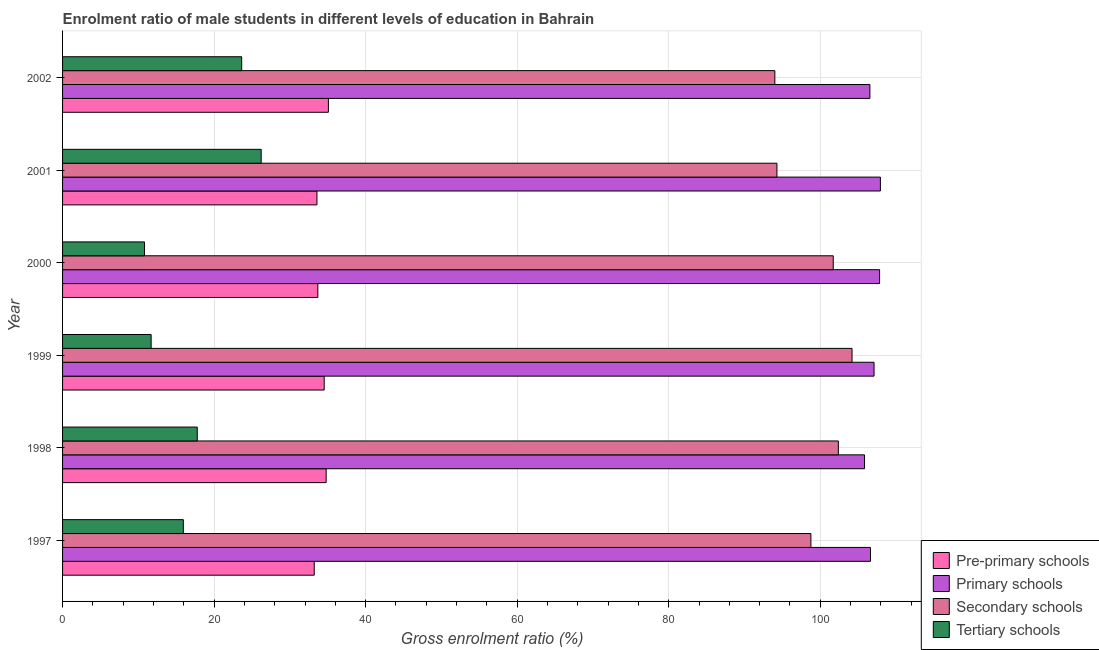How many different coloured bars are there?
Your answer should be very brief. 4. Are the number of bars on each tick of the Y-axis equal?
Your response must be concise. Yes. How many bars are there on the 2nd tick from the top?
Keep it short and to the point. 4. How many bars are there on the 3rd tick from the bottom?
Offer a very short reply. 4. What is the label of the 3rd group of bars from the top?
Your answer should be compact. 2000. What is the gross enrolment ratio(female) in primary schools in 1999?
Offer a very short reply. 107.1. Across all years, what is the maximum gross enrolment ratio(female) in primary schools?
Your answer should be compact. 107.94. Across all years, what is the minimum gross enrolment ratio(female) in tertiary schools?
Keep it short and to the point. 10.81. In which year was the gross enrolment ratio(female) in primary schools minimum?
Make the answer very short. 1998. What is the total gross enrolment ratio(female) in secondary schools in the graph?
Offer a very short reply. 595.35. What is the difference between the gross enrolment ratio(female) in secondary schools in 1999 and that in 2002?
Ensure brevity in your answer.  10.19. What is the difference between the gross enrolment ratio(female) in pre-primary schools in 1999 and the gross enrolment ratio(female) in secondary schools in 1998?
Keep it short and to the point. -67.86. What is the average gross enrolment ratio(female) in pre-primary schools per year?
Make the answer very short. 34.15. In the year 2001, what is the difference between the gross enrolment ratio(female) in tertiary schools and gross enrolment ratio(female) in primary schools?
Make the answer very short. -81.72. Is the difference between the gross enrolment ratio(female) in tertiary schools in 1999 and 2000 greater than the difference between the gross enrolment ratio(female) in secondary schools in 1999 and 2000?
Your answer should be compact. No. What is the difference between the highest and the second highest gross enrolment ratio(female) in primary schools?
Make the answer very short. 0.11. What is the difference between the highest and the lowest gross enrolment ratio(female) in primary schools?
Your response must be concise. 2.09. Is the sum of the gross enrolment ratio(female) in primary schools in 1997 and 1999 greater than the maximum gross enrolment ratio(female) in pre-primary schools across all years?
Give a very brief answer. Yes. What does the 4th bar from the top in 1999 represents?
Provide a short and direct response. Pre-primary schools. What does the 3rd bar from the bottom in 1997 represents?
Provide a short and direct response. Secondary schools. Is it the case that in every year, the sum of the gross enrolment ratio(female) in pre-primary schools and gross enrolment ratio(female) in primary schools is greater than the gross enrolment ratio(female) in secondary schools?
Provide a short and direct response. Yes. How many bars are there?
Offer a terse response. 24. Are all the bars in the graph horizontal?
Offer a very short reply. Yes. What is the difference between two consecutive major ticks on the X-axis?
Offer a very short reply. 20. What is the title of the graph?
Make the answer very short. Enrolment ratio of male students in different levels of education in Bahrain. What is the label or title of the Y-axis?
Your answer should be compact. Year. What is the Gross enrolment ratio (%) in Pre-primary schools in 1997?
Give a very brief answer. 33.22. What is the Gross enrolment ratio (%) of Primary schools in 1997?
Provide a short and direct response. 106.63. What is the Gross enrolment ratio (%) of Secondary schools in 1997?
Offer a terse response. 98.76. What is the Gross enrolment ratio (%) in Tertiary schools in 1997?
Ensure brevity in your answer.  15.94. What is the Gross enrolment ratio (%) in Pre-primary schools in 1998?
Give a very brief answer. 34.79. What is the Gross enrolment ratio (%) in Primary schools in 1998?
Provide a short and direct response. 105.84. What is the Gross enrolment ratio (%) in Secondary schools in 1998?
Your answer should be very brief. 102.39. What is the Gross enrolment ratio (%) of Tertiary schools in 1998?
Your answer should be very brief. 17.78. What is the Gross enrolment ratio (%) of Pre-primary schools in 1999?
Provide a succinct answer. 34.53. What is the Gross enrolment ratio (%) in Primary schools in 1999?
Your answer should be very brief. 107.1. What is the Gross enrolment ratio (%) of Secondary schools in 1999?
Give a very brief answer. 104.19. What is the Gross enrolment ratio (%) in Tertiary schools in 1999?
Your answer should be compact. 11.69. What is the Gross enrolment ratio (%) in Pre-primary schools in 2000?
Ensure brevity in your answer.  33.69. What is the Gross enrolment ratio (%) of Primary schools in 2000?
Ensure brevity in your answer.  107.83. What is the Gross enrolment ratio (%) in Secondary schools in 2000?
Your answer should be compact. 101.72. What is the Gross enrolment ratio (%) of Tertiary schools in 2000?
Make the answer very short. 10.81. What is the Gross enrolment ratio (%) of Pre-primary schools in 2001?
Make the answer very short. 33.57. What is the Gross enrolment ratio (%) in Primary schools in 2001?
Give a very brief answer. 107.94. What is the Gross enrolment ratio (%) of Secondary schools in 2001?
Your response must be concise. 94.28. What is the Gross enrolment ratio (%) in Tertiary schools in 2001?
Provide a succinct answer. 26.21. What is the Gross enrolment ratio (%) of Pre-primary schools in 2002?
Offer a very short reply. 35.08. What is the Gross enrolment ratio (%) in Primary schools in 2002?
Offer a terse response. 106.55. What is the Gross enrolment ratio (%) of Secondary schools in 2002?
Ensure brevity in your answer.  94.01. What is the Gross enrolment ratio (%) of Tertiary schools in 2002?
Offer a terse response. 23.64. Across all years, what is the maximum Gross enrolment ratio (%) in Pre-primary schools?
Your answer should be compact. 35.08. Across all years, what is the maximum Gross enrolment ratio (%) in Primary schools?
Your answer should be very brief. 107.94. Across all years, what is the maximum Gross enrolment ratio (%) in Secondary schools?
Your response must be concise. 104.19. Across all years, what is the maximum Gross enrolment ratio (%) of Tertiary schools?
Make the answer very short. 26.21. Across all years, what is the minimum Gross enrolment ratio (%) of Pre-primary schools?
Provide a short and direct response. 33.22. Across all years, what is the minimum Gross enrolment ratio (%) of Primary schools?
Offer a terse response. 105.84. Across all years, what is the minimum Gross enrolment ratio (%) in Secondary schools?
Ensure brevity in your answer.  94.01. Across all years, what is the minimum Gross enrolment ratio (%) of Tertiary schools?
Give a very brief answer. 10.81. What is the total Gross enrolment ratio (%) of Pre-primary schools in the graph?
Offer a very short reply. 204.88. What is the total Gross enrolment ratio (%) in Primary schools in the graph?
Your response must be concise. 641.89. What is the total Gross enrolment ratio (%) in Secondary schools in the graph?
Offer a very short reply. 595.35. What is the total Gross enrolment ratio (%) in Tertiary schools in the graph?
Your response must be concise. 106.07. What is the difference between the Gross enrolment ratio (%) of Pre-primary schools in 1997 and that in 1998?
Provide a succinct answer. -1.57. What is the difference between the Gross enrolment ratio (%) of Primary schools in 1997 and that in 1998?
Keep it short and to the point. 0.79. What is the difference between the Gross enrolment ratio (%) of Secondary schools in 1997 and that in 1998?
Offer a very short reply. -3.62. What is the difference between the Gross enrolment ratio (%) in Tertiary schools in 1997 and that in 1998?
Give a very brief answer. -1.84. What is the difference between the Gross enrolment ratio (%) in Pre-primary schools in 1997 and that in 1999?
Give a very brief answer. -1.31. What is the difference between the Gross enrolment ratio (%) in Primary schools in 1997 and that in 1999?
Your answer should be compact. -0.47. What is the difference between the Gross enrolment ratio (%) in Secondary schools in 1997 and that in 1999?
Your response must be concise. -5.43. What is the difference between the Gross enrolment ratio (%) in Tertiary schools in 1997 and that in 1999?
Offer a terse response. 4.25. What is the difference between the Gross enrolment ratio (%) in Pre-primary schools in 1997 and that in 2000?
Ensure brevity in your answer.  -0.47. What is the difference between the Gross enrolment ratio (%) in Primary schools in 1997 and that in 2000?
Keep it short and to the point. -1.2. What is the difference between the Gross enrolment ratio (%) in Secondary schools in 1997 and that in 2000?
Keep it short and to the point. -2.95. What is the difference between the Gross enrolment ratio (%) of Tertiary schools in 1997 and that in 2000?
Your answer should be very brief. 5.13. What is the difference between the Gross enrolment ratio (%) in Pre-primary schools in 1997 and that in 2001?
Your answer should be very brief. -0.36. What is the difference between the Gross enrolment ratio (%) in Primary schools in 1997 and that in 2001?
Ensure brevity in your answer.  -1.31. What is the difference between the Gross enrolment ratio (%) of Secondary schools in 1997 and that in 2001?
Provide a short and direct response. 4.48. What is the difference between the Gross enrolment ratio (%) of Tertiary schools in 1997 and that in 2001?
Your answer should be very brief. -10.28. What is the difference between the Gross enrolment ratio (%) of Pre-primary schools in 1997 and that in 2002?
Ensure brevity in your answer.  -1.86. What is the difference between the Gross enrolment ratio (%) of Primary schools in 1997 and that in 2002?
Provide a short and direct response. 0.08. What is the difference between the Gross enrolment ratio (%) of Secondary schools in 1997 and that in 2002?
Offer a very short reply. 4.76. What is the difference between the Gross enrolment ratio (%) in Tertiary schools in 1997 and that in 2002?
Make the answer very short. -7.7. What is the difference between the Gross enrolment ratio (%) of Pre-primary schools in 1998 and that in 1999?
Provide a succinct answer. 0.26. What is the difference between the Gross enrolment ratio (%) of Primary schools in 1998 and that in 1999?
Your response must be concise. -1.26. What is the difference between the Gross enrolment ratio (%) in Secondary schools in 1998 and that in 1999?
Offer a terse response. -1.81. What is the difference between the Gross enrolment ratio (%) of Tertiary schools in 1998 and that in 1999?
Your response must be concise. 6.09. What is the difference between the Gross enrolment ratio (%) of Pre-primary schools in 1998 and that in 2000?
Keep it short and to the point. 1.1. What is the difference between the Gross enrolment ratio (%) of Primary schools in 1998 and that in 2000?
Provide a succinct answer. -1.99. What is the difference between the Gross enrolment ratio (%) of Secondary schools in 1998 and that in 2000?
Your response must be concise. 0.67. What is the difference between the Gross enrolment ratio (%) of Tertiary schools in 1998 and that in 2000?
Your answer should be very brief. 6.97. What is the difference between the Gross enrolment ratio (%) of Pre-primary schools in 1998 and that in 2001?
Provide a short and direct response. 1.22. What is the difference between the Gross enrolment ratio (%) in Primary schools in 1998 and that in 2001?
Offer a very short reply. -2.09. What is the difference between the Gross enrolment ratio (%) of Secondary schools in 1998 and that in 2001?
Ensure brevity in your answer.  8.1. What is the difference between the Gross enrolment ratio (%) of Tertiary schools in 1998 and that in 2001?
Keep it short and to the point. -8.44. What is the difference between the Gross enrolment ratio (%) in Pre-primary schools in 1998 and that in 2002?
Provide a succinct answer. -0.29. What is the difference between the Gross enrolment ratio (%) in Primary schools in 1998 and that in 2002?
Offer a terse response. -0.71. What is the difference between the Gross enrolment ratio (%) of Secondary schools in 1998 and that in 2002?
Ensure brevity in your answer.  8.38. What is the difference between the Gross enrolment ratio (%) of Tertiary schools in 1998 and that in 2002?
Give a very brief answer. -5.86. What is the difference between the Gross enrolment ratio (%) of Pre-primary schools in 1999 and that in 2000?
Keep it short and to the point. 0.84. What is the difference between the Gross enrolment ratio (%) in Primary schools in 1999 and that in 2000?
Ensure brevity in your answer.  -0.73. What is the difference between the Gross enrolment ratio (%) in Secondary schools in 1999 and that in 2000?
Your answer should be compact. 2.48. What is the difference between the Gross enrolment ratio (%) in Tertiary schools in 1999 and that in 2000?
Keep it short and to the point. 0.88. What is the difference between the Gross enrolment ratio (%) in Pre-primary schools in 1999 and that in 2001?
Keep it short and to the point. 0.96. What is the difference between the Gross enrolment ratio (%) in Primary schools in 1999 and that in 2001?
Your response must be concise. -0.84. What is the difference between the Gross enrolment ratio (%) of Secondary schools in 1999 and that in 2001?
Provide a short and direct response. 9.91. What is the difference between the Gross enrolment ratio (%) of Tertiary schools in 1999 and that in 2001?
Give a very brief answer. -14.52. What is the difference between the Gross enrolment ratio (%) of Pre-primary schools in 1999 and that in 2002?
Offer a terse response. -0.55. What is the difference between the Gross enrolment ratio (%) of Primary schools in 1999 and that in 2002?
Provide a short and direct response. 0.55. What is the difference between the Gross enrolment ratio (%) in Secondary schools in 1999 and that in 2002?
Provide a short and direct response. 10.19. What is the difference between the Gross enrolment ratio (%) of Tertiary schools in 1999 and that in 2002?
Provide a short and direct response. -11.95. What is the difference between the Gross enrolment ratio (%) of Pre-primary schools in 2000 and that in 2001?
Keep it short and to the point. 0.12. What is the difference between the Gross enrolment ratio (%) of Primary schools in 2000 and that in 2001?
Make the answer very short. -0.11. What is the difference between the Gross enrolment ratio (%) in Secondary schools in 2000 and that in 2001?
Keep it short and to the point. 7.43. What is the difference between the Gross enrolment ratio (%) in Tertiary schools in 2000 and that in 2001?
Ensure brevity in your answer.  -15.4. What is the difference between the Gross enrolment ratio (%) in Pre-primary schools in 2000 and that in 2002?
Your response must be concise. -1.39. What is the difference between the Gross enrolment ratio (%) of Primary schools in 2000 and that in 2002?
Ensure brevity in your answer.  1.28. What is the difference between the Gross enrolment ratio (%) in Secondary schools in 2000 and that in 2002?
Your response must be concise. 7.71. What is the difference between the Gross enrolment ratio (%) in Tertiary schools in 2000 and that in 2002?
Provide a succinct answer. -12.83. What is the difference between the Gross enrolment ratio (%) in Pre-primary schools in 2001 and that in 2002?
Offer a very short reply. -1.51. What is the difference between the Gross enrolment ratio (%) of Primary schools in 2001 and that in 2002?
Your answer should be compact. 1.39. What is the difference between the Gross enrolment ratio (%) of Secondary schools in 2001 and that in 2002?
Keep it short and to the point. 0.28. What is the difference between the Gross enrolment ratio (%) in Tertiary schools in 2001 and that in 2002?
Ensure brevity in your answer.  2.57. What is the difference between the Gross enrolment ratio (%) in Pre-primary schools in 1997 and the Gross enrolment ratio (%) in Primary schools in 1998?
Offer a terse response. -72.63. What is the difference between the Gross enrolment ratio (%) of Pre-primary schools in 1997 and the Gross enrolment ratio (%) of Secondary schools in 1998?
Your answer should be compact. -69.17. What is the difference between the Gross enrolment ratio (%) of Pre-primary schools in 1997 and the Gross enrolment ratio (%) of Tertiary schools in 1998?
Ensure brevity in your answer.  15.44. What is the difference between the Gross enrolment ratio (%) in Primary schools in 1997 and the Gross enrolment ratio (%) in Secondary schools in 1998?
Ensure brevity in your answer.  4.25. What is the difference between the Gross enrolment ratio (%) in Primary schools in 1997 and the Gross enrolment ratio (%) in Tertiary schools in 1998?
Ensure brevity in your answer.  88.85. What is the difference between the Gross enrolment ratio (%) in Secondary schools in 1997 and the Gross enrolment ratio (%) in Tertiary schools in 1998?
Provide a short and direct response. 80.99. What is the difference between the Gross enrolment ratio (%) of Pre-primary schools in 1997 and the Gross enrolment ratio (%) of Primary schools in 1999?
Your answer should be compact. -73.88. What is the difference between the Gross enrolment ratio (%) of Pre-primary schools in 1997 and the Gross enrolment ratio (%) of Secondary schools in 1999?
Your answer should be very brief. -70.98. What is the difference between the Gross enrolment ratio (%) of Pre-primary schools in 1997 and the Gross enrolment ratio (%) of Tertiary schools in 1999?
Make the answer very short. 21.53. What is the difference between the Gross enrolment ratio (%) in Primary schools in 1997 and the Gross enrolment ratio (%) in Secondary schools in 1999?
Keep it short and to the point. 2.44. What is the difference between the Gross enrolment ratio (%) in Primary schools in 1997 and the Gross enrolment ratio (%) in Tertiary schools in 1999?
Offer a very short reply. 94.94. What is the difference between the Gross enrolment ratio (%) in Secondary schools in 1997 and the Gross enrolment ratio (%) in Tertiary schools in 1999?
Your response must be concise. 87.07. What is the difference between the Gross enrolment ratio (%) of Pre-primary schools in 1997 and the Gross enrolment ratio (%) of Primary schools in 2000?
Keep it short and to the point. -74.61. What is the difference between the Gross enrolment ratio (%) in Pre-primary schools in 1997 and the Gross enrolment ratio (%) in Secondary schools in 2000?
Make the answer very short. -68.5. What is the difference between the Gross enrolment ratio (%) of Pre-primary schools in 1997 and the Gross enrolment ratio (%) of Tertiary schools in 2000?
Offer a terse response. 22.41. What is the difference between the Gross enrolment ratio (%) in Primary schools in 1997 and the Gross enrolment ratio (%) in Secondary schools in 2000?
Your response must be concise. 4.92. What is the difference between the Gross enrolment ratio (%) of Primary schools in 1997 and the Gross enrolment ratio (%) of Tertiary schools in 2000?
Keep it short and to the point. 95.82. What is the difference between the Gross enrolment ratio (%) in Secondary schools in 1997 and the Gross enrolment ratio (%) in Tertiary schools in 2000?
Ensure brevity in your answer.  87.95. What is the difference between the Gross enrolment ratio (%) in Pre-primary schools in 1997 and the Gross enrolment ratio (%) in Primary schools in 2001?
Make the answer very short. -74.72. What is the difference between the Gross enrolment ratio (%) in Pre-primary schools in 1997 and the Gross enrolment ratio (%) in Secondary schools in 2001?
Your response must be concise. -61.07. What is the difference between the Gross enrolment ratio (%) of Pre-primary schools in 1997 and the Gross enrolment ratio (%) of Tertiary schools in 2001?
Provide a short and direct response. 7. What is the difference between the Gross enrolment ratio (%) of Primary schools in 1997 and the Gross enrolment ratio (%) of Secondary schools in 2001?
Your response must be concise. 12.35. What is the difference between the Gross enrolment ratio (%) of Primary schools in 1997 and the Gross enrolment ratio (%) of Tertiary schools in 2001?
Offer a very short reply. 80.42. What is the difference between the Gross enrolment ratio (%) of Secondary schools in 1997 and the Gross enrolment ratio (%) of Tertiary schools in 2001?
Keep it short and to the point. 72.55. What is the difference between the Gross enrolment ratio (%) in Pre-primary schools in 1997 and the Gross enrolment ratio (%) in Primary schools in 2002?
Make the answer very short. -73.33. What is the difference between the Gross enrolment ratio (%) in Pre-primary schools in 1997 and the Gross enrolment ratio (%) in Secondary schools in 2002?
Offer a very short reply. -60.79. What is the difference between the Gross enrolment ratio (%) of Pre-primary schools in 1997 and the Gross enrolment ratio (%) of Tertiary schools in 2002?
Offer a terse response. 9.58. What is the difference between the Gross enrolment ratio (%) of Primary schools in 1997 and the Gross enrolment ratio (%) of Secondary schools in 2002?
Provide a short and direct response. 12.63. What is the difference between the Gross enrolment ratio (%) of Primary schools in 1997 and the Gross enrolment ratio (%) of Tertiary schools in 2002?
Your response must be concise. 82.99. What is the difference between the Gross enrolment ratio (%) in Secondary schools in 1997 and the Gross enrolment ratio (%) in Tertiary schools in 2002?
Offer a very short reply. 75.12. What is the difference between the Gross enrolment ratio (%) of Pre-primary schools in 1998 and the Gross enrolment ratio (%) of Primary schools in 1999?
Keep it short and to the point. -72.31. What is the difference between the Gross enrolment ratio (%) of Pre-primary schools in 1998 and the Gross enrolment ratio (%) of Secondary schools in 1999?
Ensure brevity in your answer.  -69.41. What is the difference between the Gross enrolment ratio (%) in Pre-primary schools in 1998 and the Gross enrolment ratio (%) in Tertiary schools in 1999?
Make the answer very short. 23.1. What is the difference between the Gross enrolment ratio (%) of Primary schools in 1998 and the Gross enrolment ratio (%) of Secondary schools in 1999?
Your response must be concise. 1.65. What is the difference between the Gross enrolment ratio (%) in Primary schools in 1998 and the Gross enrolment ratio (%) in Tertiary schools in 1999?
Provide a succinct answer. 94.15. What is the difference between the Gross enrolment ratio (%) in Secondary schools in 1998 and the Gross enrolment ratio (%) in Tertiary schools in 1999?
Keep it short and to the point. 90.7. What is the difference between the Gross enrolment ratio (%) in Pre-primary schools in 1998 and the Gross enrolment ratio (%) in Primary schools in 2000?
Make the answer very short. -73.04. What is the difference between the Gross enrolment ratio (%) in Pre-primary schools in 1998 and the Gross enrolment ratio (%) in Secondary schools in 2000?
Provide a short and direct response. -66.93. What is the difference between the Gross enrolment ratio (%) of Pre-primary schools in 1998 and the Gross enrolment ratio (%) of Tertiary schools in 2000?
Provide a succinct answer. 23.98. What is the difference between the Gross enrolment ratio (%) of Primary schools in 1998 and the Gross enrolment ratio (%) of Secondary schools in 2000?
Ensure brevity in your answer.  4.13. What is the difference between the Gross enrolment ratio (%) of Primary schools in 1998 and the Gross enrolment ratio (%) of Tertiary schools in 2000?
Keep it short and to the point. 95.03. What is the difference between the Gross enrolment ratio (%) of Secondary schools in 1998 and the Gross enrolment ratio (%) of Tertiary schools in 2000?
Provide a succinct answer. 91.57. What is the difference between the Gross enrolment ratio (%) in Pre-primary schools in 1998 and the Gross enrolment ratio (%) in Primary schools in 2001?
Keep it short and to the point. -73.15. What is the difference between the Gross enrolment ratio (%) of Pre-primary schools in 1998 and the Gross enrolment ratio (%) of Secondary schools in 2001?
Give a very brief answer. -59.5. What is the difference between the Gross enrolment ratio (%) of Pre-primary schools in 1998 and the Gross enrolment ratio (%) of Tertiary schools in 2001?
Offer a terse response. 8.57. What is the difference between the Gross enrolment ratio (%) of Primary schools in 1998 and the Gross enrolment ratio (%) of Secondary schools in 2001?
Your response must be concise. 11.56. What is the difference between the Gross enrolment ratio (%) of Primary schools in 1998 and the Gross enrolment ratio (%) of Tertiary schools in 2001?
Ensure brevity in your answer.  79.63. What is the difference between the Gross enrolment ratio (%) in Secondary schools in 1998 and the Gross enrolment ratio (%) in Tertiary schools in 2001?
Keep it short and to the point. 76.17. What is the difference between the Gross enrolment ratio (%) in Pre-primary schools in 1998 and the Gross enrolment ratio (%) in Primary schools in 2002?
Make the answer very short. -71.76. What is the difference between the Gross enrolment ratio (%) of Pre-primary schools in 1998 and the Gross enrolment ratio (%) of Secondary schools in 2002?
Provide a succinct answer. -59.22. What is the difference between the Gross enrolment ratio (%) in Pre-primary schools in 1998 and the Gross enrolment ratio (%) in Tertiary schools in 2002?
Offer a terse response. 11.15. What is the difference between the Gross enrolment ratio (%) of Primary schools in 1998 and the Gross enrolment ratio (%) of Secondary schools in 2002?
Give a very brief answer. 11.84. What is the difference between the Gross enrolment ratio (%) of Primary schools in 1998 and the Gross enrolment ratio (%) of Tertiary schools in 2002?
Keep it short and to the point. 82.2. What is the difference between the Gross enrolment ratio (%) in Secondary schools in 1998 and the Gross enrolment ratio (%) in Tertiary schools in 2002?
Keep it short and to the point. 78.75. What is the difference between the Gross enrolment ratio (%) in Pre-primary schools in 1999 and the Gross enrolment ratio (%) in Primary schools in 2000?
Make the answer very short. -73.3. What is the difference between the Gross enrolment ratio (%) in Pre-primary schools in 1999 and the Gross enrolment ratio (%) in Secondary schools in 2000?
Give a very brief answer. -67.19. What is the difference between the Gross enrolment ratio (%) in Pre-primary schools in 1999 and the Gross enrolment ratio (%) in Tertiary schools in 2000?
Provide a succinct answer. 23.72. What is the difference between the Gross enrolment ratio (%) in Primary schools in 1999 and the Gross enrolment ratio (%) in Secondary schools in 2000?
Your answer should be compact. 5.38. What is the difference between the Gross enrolment ratio (%) of Primary schools in 1999 and the Gross enrolment ratio (%) of Tertiary schools in 2000?
Ensure brevity in your answer.  96.29. What is the difference between the Gross enrolment ratio (%) in Secondary schools in 1999 and the Gross enrolment ratio (%) in Tertiary schools in 2000?
Offer a very short reply. 93.38. What is the difference between the Gross enrolment ratio (%) in Pre-primary schools in 1999 and the Gross enrolment ratio (%) in Primary schools in 2001?
Your answer should be very brief. -73.41. What is the difference between the Gross enrolment ratio (%) of Pre-primary schools in 1999 and the Gross enrolment ratio (%) of Secondary schools in 2001?
Make the answer very short. -59.75. What is the difference between the Gross enrolment ratio (%) of Pre-primary schools in 1999 and the Gross enrolment ratio (%) of Tertiary schools in 2001?
Provide a succinct answer. 8.32. What is the difference between the Gross enrolment ratio (%) in Primary schools in 1999 and the Gross enrolment ratio (%) in Secondary schools in 2001?
Provide a short and direct response. 12.82. What is the difference between the Gross enrolment ratio (%) of Primary schools in 1999 and the Gross enrolment ratio (%) of Tertiary schools in 2001?
Keep it short and to the point. 80.89. What is the difference between the Gross enrolment ratio (%) in Secondary schools in 1999 and the Gross enrolment ratio (%) in Tertiary schools in 2001?
Keep it short and to the point. 77.98. What is the difference between the Gross enrolment ratio (%) in Pre-primary schools in 1999 and the Gross enrolment ratio (%) in Primary schools in 2002?
Your answer should be very brief. -72.02. What is the difference between the Gross enrolment ratio (%) of Pre-primary schools in 1999 and the Gross enrolment ratio (%) of Secondary schools in 2002?
Your response must be concise. -59.48. What is the difference between the Gross enrolment ratio (%) of Pre-primary schools in 1999 and the Gross enrolment ratio (%) of Tertiary schools in 2002?
Offer a terse response. 10.89. What is the difference between the Gross enrolment ratio (%) of Primary schools in 1999 and the Gross enrolment ratio (%) of Secondary schools in 2002?
Your response must be concise. 13.09. What is the difference between the Gross enrolment ratio (%) of Primary schools in 1999 and the Gross enrolment ratio (%) of Tertiary schools in 2002?
Keep it short and to the point. 83.46. What is the difference between the Gross enrolment ratio (%) in Secondary schools in 1999 and the Gross enrolment ratio (%) in Tertiary schools in 2002?
Provide a succinct answer. 80.55. What is the difference between the Gross enrolment ratio (%) of Pre-primary schools in 2000 and the Gross enrolment ratio (%) of Primary schools in 2001?
Provide a succinct answer. -74.25. What is the difference between the Gross enrolment ratio (%) in Pre-primary schools in 2000 and the Gross enrolment ratio (%) in Secondary schools in 2001?
Give a very brief answer. -60.59. What is the difference between the Gross enrolment ratio (%) of Pre-primary schools in 2000 and the Gross enrolment ratio (%) of Tertiary schools in 2001?
Provide a short and direct response. 7.48. What is the difference between the Gross enrolment ratio (%) in Primary schools in 2000 and the Gross enrolment ratio (%) in Secondary schools in 2001?
Ensure brevity in your answer.  13.55. What is the difference between the Gross enrolment ratio (%) in Primary schools in 2000 and the Gross enrolment ratio (%) in Tertiary schools in 2001?
Your answer should be compact. 81.62. What is the difference between the Gross enrolment ratio (%) of Secondary schools in 2000 and the Gross enrolment ratio (%) of Tertiary schools in 2001?
Give a very brief answer. 75.5. What is the difference between the Gross enrolment ratio (%) in Pre-primary schools in 2000 and the Gross enrolment ratio (%) in Primary schools in 2002?
Keep it short and to the point. -72.86. What is the difference between the Gross enrolment ratio (%) of Pre-primary schools in 2000 and the Gross enrolment ratio (%) of Secondary schools in 2002?
Provide a succinct answer. -60.32. What is the difference between the Gross enrolment ratio (%) of Pre-primary schools in 2000 and the Gross enrolment ratio (%) of Tertiary schools in 2002?
Ensure brevity in your answer.  10.05. What is the difference between the Gross enrolment ratio (%) of Primary schools in 2000 and the Gross enrolment ratio (%) of Secondary schools in 2002?
Make the answer very short. 13.82. What is the difference between the Gross enrolment ratio (%) of Primary schools in 2000 and the Gross enrolment ratio (%) of Tertiary schools in 2002?
Give a very brief answer. 84.19. What is the difference between the Gross enrolment ratio (%) in Secondary schools in 2000 and the Gross enrolment ratio (%) in Tertiary schools in 2002?
Offer a very short reply. 78.07. What is the difference between the Gross enrolment ratio (%) of Pre-primary schools in 2001 and the Gross enrolment ratio (%) of Primary schools in 2002?
Your answer should be very brief. -72.98. What is the difference between the Gross enrolment ratio (%) in Pre-primary schools in 2001 and the Gross enrolment ratio (%) in Secondary schools in 2002?
Keep it short and to the point. -60.43. What is the difference between the Gross enrolment ratio (%) in Pre-primary schools in 2001 and the Gross enrolment ratio (%) in Tertiary schools in 2002?
Your answer should be very brief. 9.93. What is the difference between the Gross enrolment ratio (%) of Primary schools in 2001 and the Gross enrolment ratio (%) of Secondary schools in 2002?
Your response must be concise. 13.93. What is the difference between the Gross enrolment ratio (%) in Primary schools in 2001 and the Gross enrolment ratio (%) in Tertiary schools in 2002?
Provide a short and direct response. 84.3. What is the difference between the Gross enrolment ratio (%) of Secondary schools in 2001 and the Gross enrolment ratio (%) of Tertiary schools in 2002?
Your response must be concise. 70.64. What is the average Gross enrolment ratio (%) of Pre-primary schools per year?
Your answer should be compact. 34.15. What is the average Gross enrolment ratio (%) in Primary schools per year?
Your answer should be very brief. 106.98. What is the average Gross enrolment ratio (%) in Secondary schools per year?
Your answer should be very brief. 99.22. What is the average Gross enrolment ratio (%) of Tertiary schools per year?
Provide a succinct answer. 17.68. In the year 1997, what is the difference between the Gross enrolment ratio (%) in Pre-primary schools and Gross enrolment ratio (%) in Primary schools?
Offer a very short reply. -73.41. In the year 1997, what is the difference between the Gross enrolment ratio (%) of Pre-primary schools and Gross enrolment ratio (%) of Secondary schools?
Your answer should be very brief. -65.55. In the year 1997, what is the difference between the Gross enrolment ratio (%) in Pre-primary schools and Gross enrolment ratio (%) in Tertiary schools?
Give a very brief answer. 17.28. In the year 1997, what is the difference between the Gross enrolment ratio (%) in Primary schools and Gross enrolment ratio (%) in Secondary schools?
Provide a short and direct response. 7.87. In the year 1997, what is the difference between the Gross enrolment ratio (%) in Primary schools and Gross enrolment ratio (%) in Tertiary schools?
Make the answer very short. 90.69. In the year 1997, what is the difference between the Gross enrolment ratio (%) in Secondary schools and Gross enrolment ratio (%) in Tertiary schools?
Ensure brevity in your answer.  82.83. In the year 1998, what is the difference between the Gross enrolment ratio (%) of Pre-primary schools and Gross enrolment ratio (%) of Primary schools?
Provide a succinct answer. -71.06. In the year 1998, what is the difference between the Gross enrolment ratio (%) of Pre-primary schools and Gross enrolment ratio (%) of Secondary schools?
Ensure brevity in your answer.  -67.6. In the year 1998, what is the difference between the Gross enrolment ratio (%) of Pre-primary schools and Gross enrolment ratio (%) of Tertiary schools?
Make the answer very short. 17.01. In the year 1998, what is the difference between the Gross enrolment ratio (%) of Primary schools and Gross enrolment ratio (%) of Secondary schools?
Keep it short and to the point. 3.46. In the year 1998, what is the difference between the Gross enrolment ratio (%) of Primary schools and Gross enrolment ratio (%) of Tertiary schools?
Ensure brevity in your answer.  88.07. In the year 1998, what is the difference between the Gross enrolment ratio (%) in Secondary schools and Gross enrolment ratio (%) in Tertiary schools?
Provide a short and direct response. 84.61. In the year 1999, what is the difference between the Gross enrolment ratio (%) in Pre-primary schools and Gross enrolment ratio (%) in Primary schools?
Your response must be concise. -72.57. In the year 1999, what is the difference between the Gross enrolment ratio (%) of Pre-primary schools and Gross enrolment ratio (%) of Secondary schools?
Offer a terse response. -69.66. In the year 1999, what is the difference between the Gross enrolment ratio (%) in Pre-primary schools and Gross enrolment ratio (%) in Tertiary schools?
Your response must be concise. 22.84. In the year 1999, what is the difference between the Gross enrolment ratio (%) of Primary schools and Gross enrolment ratio (%) of Secondary schools?
Ensure brevity in your answer.  2.91. In the year 1999, what is the difference between the Gross enrolment ratio (%) of Primary schools and Gross enrolment ratio (%) of Tertiary schools?
Make the answer very short. 95.41. In the year 1999, what is the difference between the Gross enrolment ratio (%) in Secondary schools and Gross enrolment ratio (%) in Tertiary schools?
Your answer should be compact. 92.5. In the year 2000, what is the difference between the Gross enrolment ratio (%) in Pre-primary schools and Gross enrolment ratio (%) in Primary schools?
Give a very brief answer. -74.14. In the year 2000, what is the difference between the Gross enrolment ratio (%) in Pre-primary schools and Gross enrolment ratio (%) in Secondary schools?
Give a very brief answer. -68.02. In the year 2000, what is the difference between the Gross enrolment ratio (%) of Pre-primary schools and Gross enrolment ratio (%) of Tertiary schools?
Offer a very short reply. 22.88. In the year 2000, what is the difference between the Gross enrolment ratio (%) of Primary schools and Gross enrolment ratio (%) of Secondary schools?
Offer a terse response. 6.12. In the year 2000, what is the difference between the Gross enrolment ratio (%) of Primary schools and Gross enrolment ratio (%) of Tertiary schools?
Provide a short and direct response. 97.02. In the year 2000, what is the difference between the Gross enrolment ratio (%) of Secondary schools and Gross enrolment ratio (%) of Tertiary schools?
Your response must be concise. 90.9. In the year 2001, what is the difference between the Gross enrolment ratio (%) of Pre-primary schools and Gross enrolment ratio (%) of Primary schools?
Provide a succinct answer. -74.36. In the year 2001, what is the difference between the Gross enrolment ratio (%) in Pre-primary schools and Gross enrolment ratio (%) in Secondary schools?
Your answer should be compact. -60.71. In the year 2001, what is the difference between the Gross enrolment ratio (%) of Pre-primary schools and Gross enrolment ratio (%) of Tertiary schools?
Make the answer very short. 7.36. In the year 2001, what is the difference between the Gross enrolment ratio (%) of Primary schools and Gross enrolment ratio (%) of Secondary schools?
Provide a succinct answer. 13.65. In the year 2001, what is the difference between the Gross enrolment ratio (%) in Primary schools and Gross enrolment ratio (%) in Tertiary schools?
Provide a succinct answer. 81.72. In the year 2001, what is the difference between the Gross enrolment ratio (%) of Secondary schools and Gross enrolment ratio (%) of Tertiary schools?
Your answer should be compact. 68.07. In the year 2002, what is the difference between the Gross enrolment ratio (%) in Pre-primary schools and Gross enrolment ratio (%) in Primary schools?
Make the answer very short. -71.47. In the year 2002, what is the difference between the Gross enrolment ratio (%) of Pre-primary schools and Gross enrolment ratio (%) of Secondary schools?
Provide a succinct answer. -58.92. In the year 2002, what is the difference between the Gross enrolment ratio (%) of Pre-primary schools and Gross enrolment ratio (%) of Tertiary schools?
Keep it short and to the point. 11.44. In the year 2002, what is the difference between the Gross enrolment ratio (%) in Primary schools and Gross enrolment ratio (%) in Secondary schools?
Give a very brief answer. 12.54. In the year 2002, what is the difference between the Gross enrolment ratio (%) of Primary schools and Gross enrolment ratio (%) of Tertiary schools?
Keep it short and to the point. 82.91. In the year 2002, what is the difference between the Gross enrolment ratio (%) of Secondary schools and Gross enrolment ratio (%) of Tertiary schools?
Keep it short and to the point. 70.37. What is the ratio of the Gross enrolment ratio (%) of Pre-primary schools in 1997 to that in 1998?
Give a very brief answer. 0.95. What is the ratio of the Gross enrolment ratio (%) in Primary schools in 1997 to that in 1998?
Your answer should be very brief. 1.01. What is the ratio of the Gross enrolment ratio (%) in Secondary schools in 1997 to that in 1998?
Your response must be concise. 0.96. What is the ratio of the Gross enrolment ratio (%) in Tertiary schools in 1997 to that in 1998?
Keep it short and to the point. 0.9. What is the ratio of the Gross enrolment ratio (%) of Primary schools in 1997 to that in 1999?
Your answer should be very brief. 1. What is the ratio of the Gross enrolment ratio (%) of Secondary schools in 1997 to that in 1999?
Offer a very short reply. 0.95. What is the ratio of the Gross enrolment ratio (%) of Tertiary schools in 1997 to that in 1999?
Offer a very short reply. 1.36. What is the ratio of the Gross enrolment ratio (%) of Pre-primary schools in 1997 to that in 2000?
Your response must be concise. 0.99. What is the ratio of the Gross enrolment ratio (%) in Primary schools in 1997 to that in 2000?
Ensure brevity in your answer.  0.99. What is the ratio of the Gross enrolment ratio (%) of Secondary schools in 1997 to that in 2000?
Your answer should be very brief. 0.97. What is the ratio of the Gross enrolment ratio (%) in Tertiary schools in 1997 to that in 2000?
Ensure brevity in your answer.  1.47. What is the ratio of the Gross enrolment ratio (%) in Primary schools in 1997 to that in 2001?
Offer a terse response. 0.99. What is the ratio of the Gross enrolment ratio (%) in Secondary schools in 1997 to that in 2001?
Give a very brief answer. 1.05. What is the ratio of the Gross enrolment ratio (%) in Tertiary schools in 1997 to that in 2001?
Offer a very short reply. 0.61. What is the ratio of the Gross enrolment ratio (%) of Pre-primary schools in 1997 to that in 2002?
Ensure brevity in your answer.  0.95. What is the ratio of the Gross enrolment ratio (%) of Secondary schools in 1997 to that in 2002?
Make the answer very short. 1.05. What is the ratio of the Gross enrolment ratio (%) in Tertiary schools in 1997 to that in 2002?
Ensure brevity in your answer.  0.67. What is the ratio of the Gross enrolment ratio (%) in Pre-primary schools in 1998 to that in 1999?
Ensure brevity in your answer.  1.01. What is the ratio of the Gross enrolment ratio (%) in Primary schools in 1998 to that in 1999?
Make the answer very short. 0.99. What is the ratio of the Gross enrolment ratio (%) of Secondary schools in 1998 to that in 1999?
Offer a terse response. 0.98. What is the ratio of the Gross enrolment ratio (%) in Tertiary schools in 1998 to that in 1999?
Ensure brevity in your answer.  1.52. What is the ratio of the Gross enrolment ratio (%) in Pre-primary schools in 1998 to that in 2000?
Ensure brevity in your answer.  1.03. What is the ratio of the Gross enrolment ratio (%) of Primary schools in 1998 to that in 2000?
Give a very brief answer. 0.98. What is the ratio of the Gross enrolment ratio (%) in Secondary schools in 1998 to that in 2000?
Ensure brevity in your answer.  1.01. What is the ratio of the Gross enrolment ratio (%) of Tertiary schools in 1998 to that in 2000?
Keep it short and to the point. 1.64. What is the ratio of the Gross enrolment ratio (%) in Pre-primary schools in 1998 to that in 2001?
Give a very brief answer. 1.04. What is the ratio of the Gross enrolment ratio (%) in Primary schools in 1998 to that in 2001?
Your answer should be compact. 0.98. What is the ratio of the Gross enrolment ratio (%) in Secondary schools in 1998 to that in 2001?
Ensure brevity in your answer.  1.09. What is the ratio of the Gross enrolment ratio (%) of Tertiary schools in 1998 to that in 2001?
Keep it short and to the point. 0.68. What is the ratio of the Gross enrolment ratio (%) in Primary schools in 1998 to that in 2002?
Ensure brevity in your answer.  0.99. What is the ratio of the Gross enrolment ratio (%) in Secondary schools in 1998 to that in 2002?
Offer a terse response. 1.09. What is the ratio of the Gross enrolment ratio (%) of Tertiary schools in 1998 to that in 2002?
Offer a very short reply. 0.75. What is the ratio of the Gross enrolment ratio (%) of Pre-primary schools in 1999 to that in 2000?
Provide a succinct answer. 1.02. What is the ratio of the Gross enrolment ratio (%) of Secondary schools in 1999 to that in 2000?
Give a very brief answer. 1.02. What is the ratio of the Gross enrolment ratio (%) in Tertiary schools in 1999 to that in 2000?
Provide a short and direct response. 1.08. What is the ratio of the Gross enrolment ratio (%) of Pre-primary schools in 1999 to that in 2001?
Your answer should be compact. 1.03. What is the ratio of the Gross enrolment ratio (%) of Primary schools in 1999 to that in 2001?
Offer a terse response. 0.99. What is the ratio of the Gross enrolment ratio (%) of Secondary schools in 1999 to that in 2001?
Make the answer very short. 1.11. What is the ratio of the Gross enrolment ratio (%) in Tertiary schools in 1999 to that in 2001?
Give a very brief answer. 0.45. What is the ratio of the Gross enrolment ratio (%) of Pre-primary schools in 1999 to that in 2002?
Provide a succinct answer. 0.98. What is the ratio of the Gross enrolment ratio (%) in Secondary schools in 1999 to that in 2002?
Provide a short and direct response. 1.11. What is the ratio of the Gross enrolment ratio (%) in Tertiary schools in 1999 to that in 2002?
Give a very brief answer. 0.49. What is the ratio of the Gross enrolment ratio (%) in Secondary schools in 2000 to that in 2001?
Provide a short and direct response. 1.08. What is the ratio of the Gross enrolment ratio (%) of Tertiary schools in 2000 to that in 2001?
Your answer should be very brief. 0.41. What is the ratio of the Gross enrolment ratio (%) of Pre-primary schools in 2000 to that in 2002?
Make the answer very short. 0.96. What is the ratio of the Gross enrolment ratio (%) of Secondary schools in 2000 to that in 2002?
Make the answer very short. 1.08. What is the ratio of the Gross enrolment ratio (%) of Tertiary schools in 2000 to that in 2002?
Offer a terse response. 0.46. What is the ratio of the Gross enrolment ratio (%) of Tertiary schools in 2001 to that in 2002?
Offer a very short reply. 1.11. What is the difference between the highest and the second highest Gross enrolment ratio (%) of Pre-primary schools?
Ensure brevity in your answer.  0.29. What is the difference between the highest and the second highest Gross enrolment ratio (%) in Primary schools?
Provide a short and direct response. 0.11. What is the difference between the highest and the second highest Gross enrolment ratio (%) of Secondary schools?
Keep it short and to the point. 1.81. What is the difference between the highest and the second highest Gross enrolment ratio (%) in Tertiary schools?
Provide a succinct answer. 2.57. What is the difference between the highest and the lowest Gross enrolment ratio (%) in Pre-primary schools?
Ensure brevity in your answer.  1.86. What is the difference between the highest and the lowest Gross enrolment ratio (%) of Primary schools?
Offer a very short reply. 2.09. What is the difference between the highest and the lowest Gross enrolment ratio (%) in Secondary schools?
Make the answer very short. 10.19. What is the difference between the highest and the lowest Gross enrolment ratio (%) of Tertiary schools?
Your response must be concise. 15.4. 